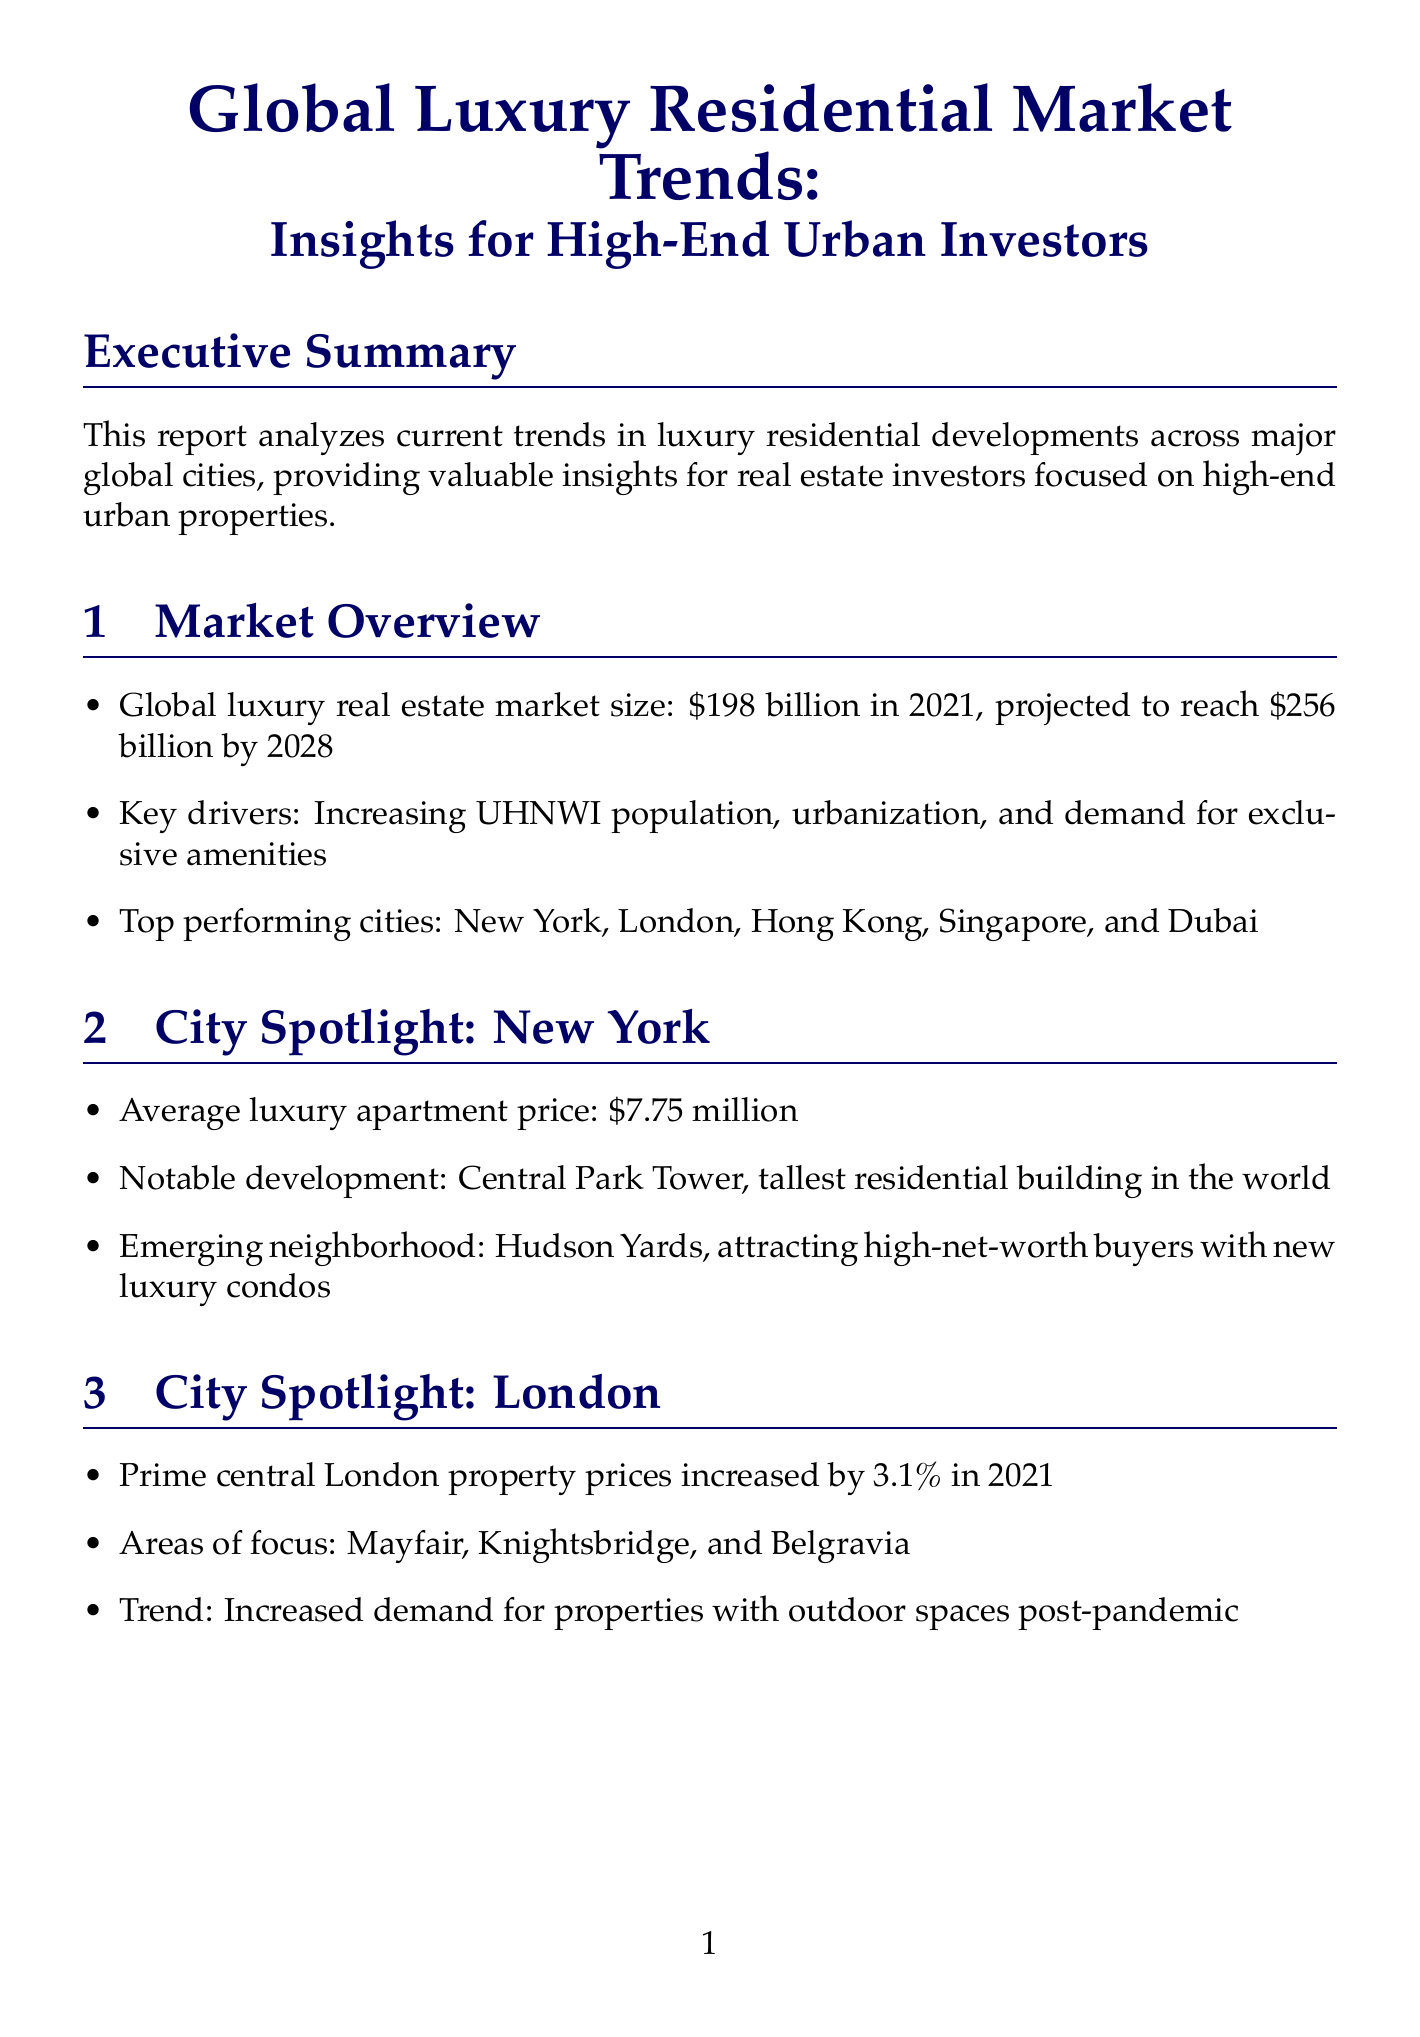what is the projected size of the global luxury real estate market by 2028? The projected size is mentioned in the Market Overview section as expected to reach $256 billion by 2028.
Answer: $256 billion what is the main emerging neighborhood in New York attracting high-net-worth buyers? The emerging neighborhood in New York highlighted in the report is Hudson Yards, which is attracting high-net-worth buyers with new luxury condos.
Answer: Hudson Yards which city is experiencing a surge in luxury condo developments? The report identifies Miami as the city experiencing a surge in luxury condo developments, attracting international investors.
Answer: Miami what percentage did prime central London property prices increase in 2021? The report provides this statistic under the London city spotlight, indicating an increase of 3.1% in 2021.
Answer: 3.1% what are some popular features in luxury developments focused on wellness? The report lists various wellness facilities that are in demand in luxury developments, including private spas, meditation rooms, and fitness centers.
Answer: Private spas, meditation rooms, and fitness centers what is one key risk factor mentioned in the report? The report enumerates several risk factors; one of them includes economic uncertainties and potential market corrections, which can impact luxury real estate investments.
Answer: Economic uncertainties what type of ownership is gaining popularity in luxury residential investments? The report indicates that fractional ownership and branded residences are becoming increasingly popular among luxury investors.
Answer: Fractional ownership and branded residences which project is described as ultra-luxury development on the Palm Jumeirah? The report features The Royal Atlantis Residences as the ultra-luxury development on the Palm Jumeirah.
Answer: The Royal Atlantis Residences how many residential units are offered by The Royal Atlantis Residences? The number of residential units offered by The Royal Atlantis Residences is specified in the report, which mentions a total of 231 units.
Answer: 231 units 